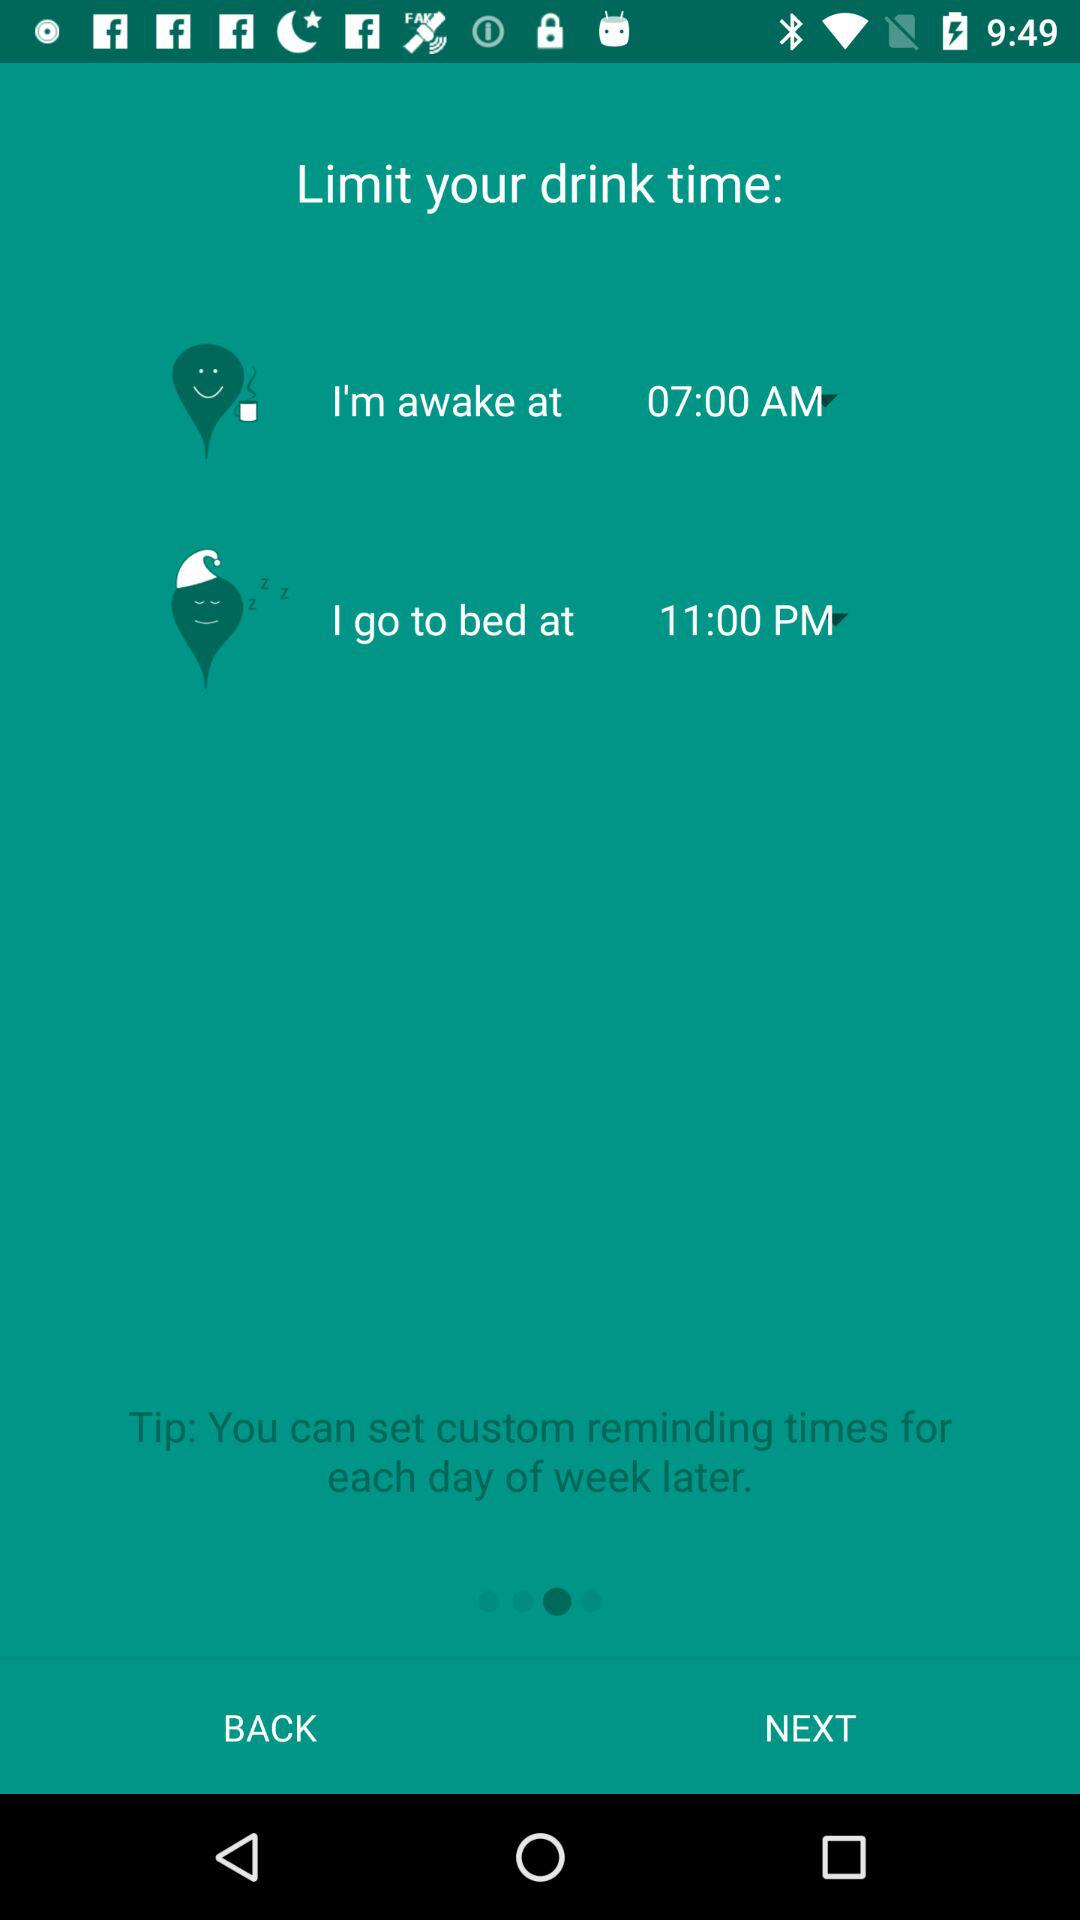What is bedtime? The bedtime is 11:00 PM. 